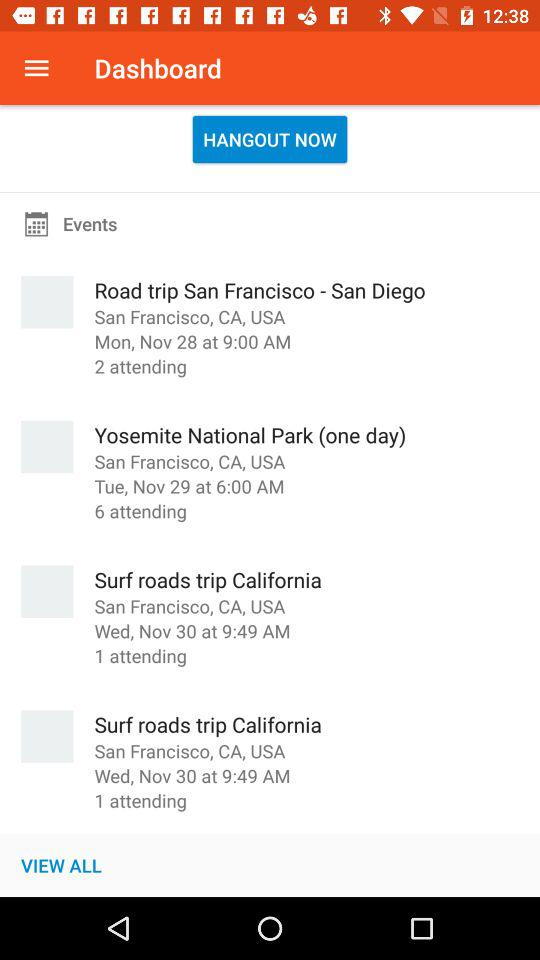What is the date and time of "Road trip San Francisco - San Diego" event? The date and time of the event is Monday, November 28 and 9:00 AM respectively. 